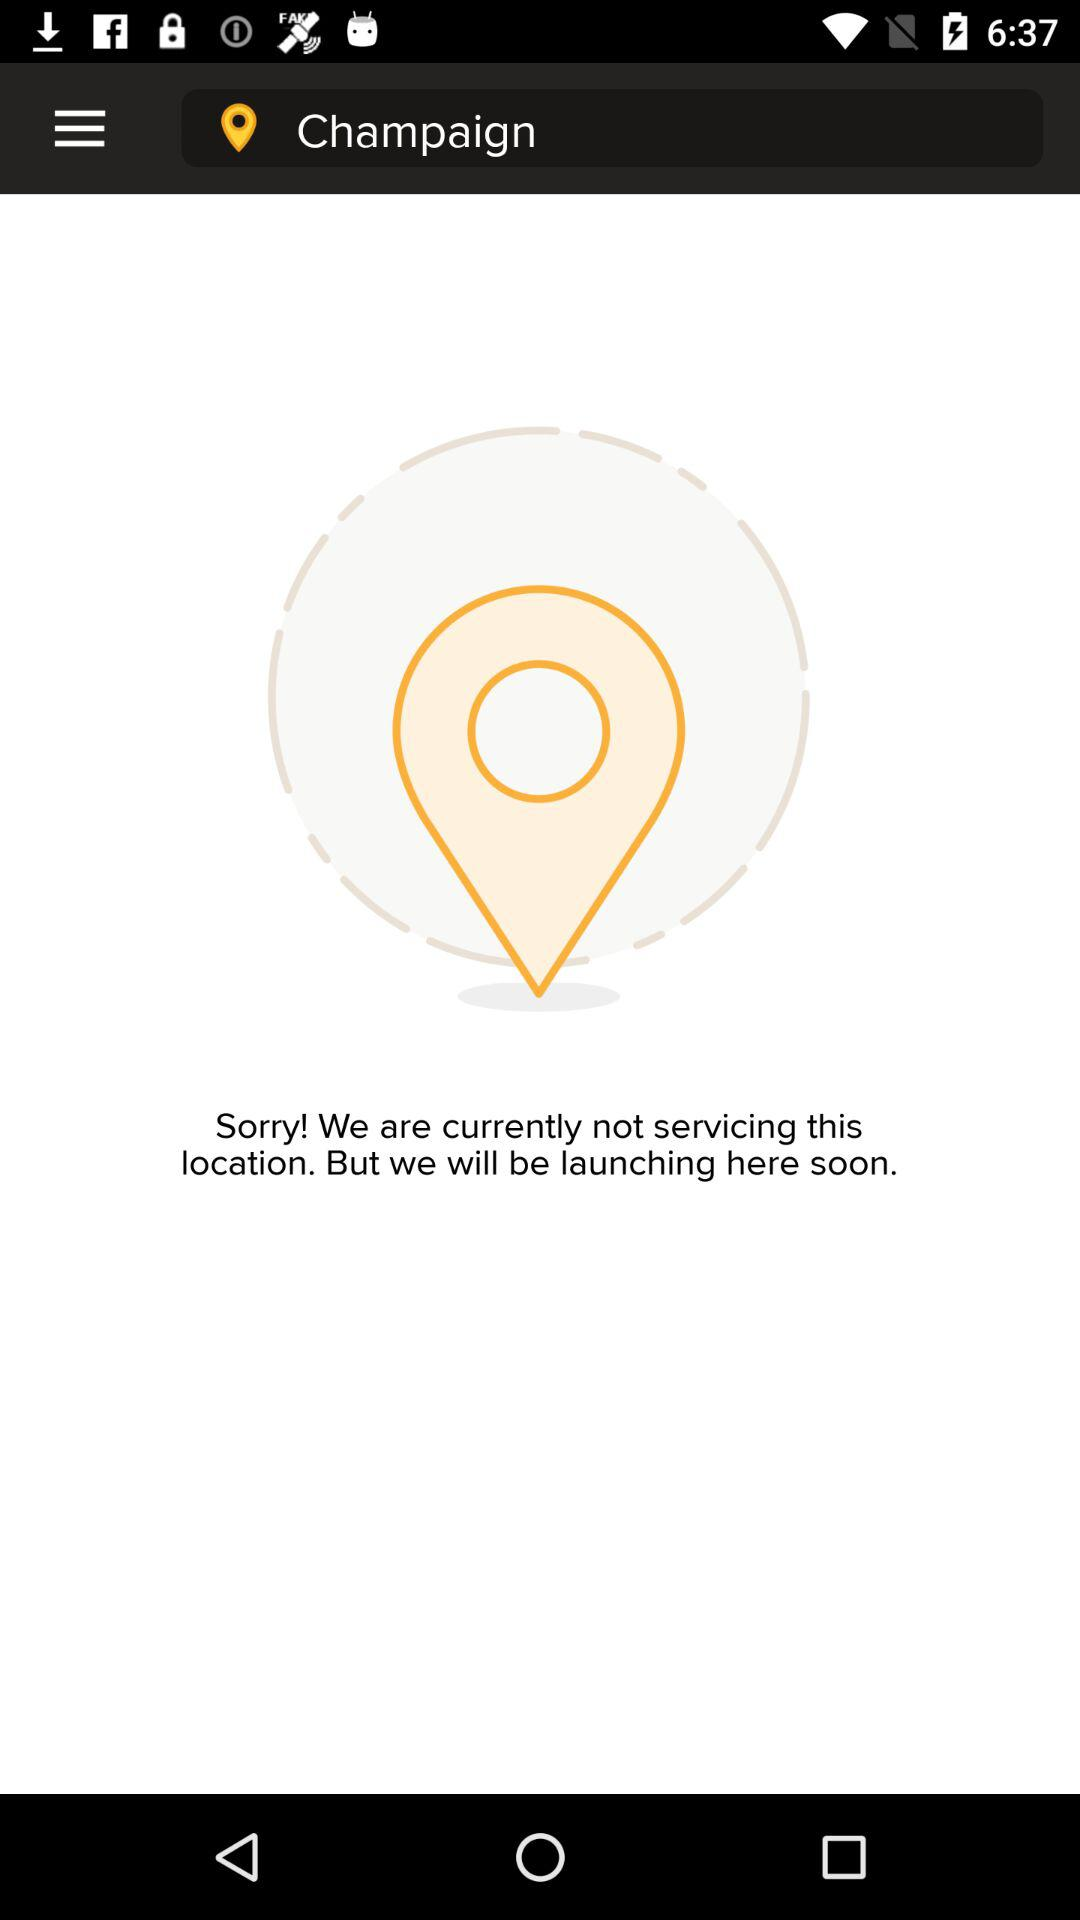Where can we get service?
When the provided information is insufficient, respond with <no answer>. <no answer> 